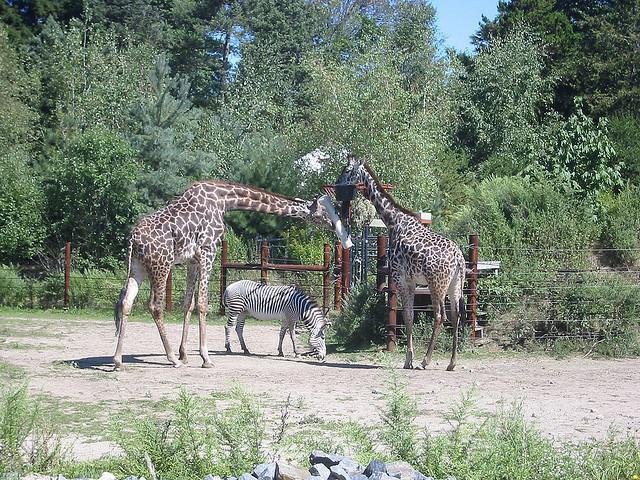How many animals can be seen?
Give a very brief answer. 3. How many giraffes are there?
Give a very brief answer. 2. 